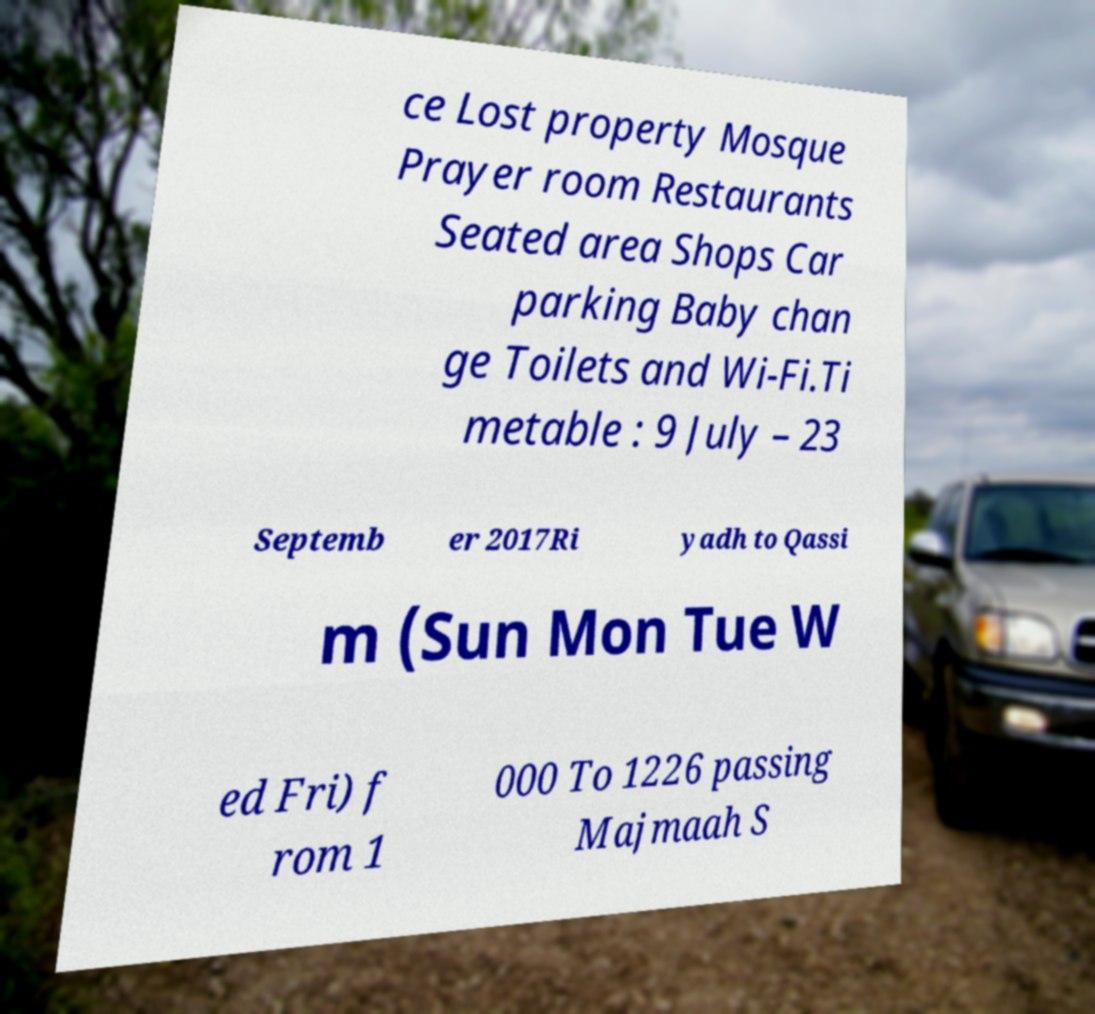For documentation purposes, I need the text within this image transcribed. Could you provide that? ce Lost property Mosque Prayer room Restaurants Seated area Shops Car parking Baby chan ge Toilets and Wi-Fi.Ti metable : 9 July – 23 Septemb er 2017Ri yadh to Qassi m (Sun Mon Tue W ed Fri) f rom 1 000 To 1226 passing Majmaah S 